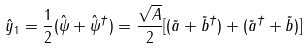Convert formula to latex. <formula><loc_0><loc_0><loc_500><loc_500>\hat { y } _ { 1 } = \frac { 1 } { 2 } ( \hat { \psi } + \hat { \psi } ^ { \dag } ) = \frac { \sqrt { A } } { 2 } [ ( \tilde { a } + \tilde { b } ^ { \dag } ) + ( \tilde { a } ^ { \dag } + \tilde { b } ) ]</formula> 